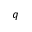<formula> <loc_0><loc_0><loc_500><loc_500>q</formula> 